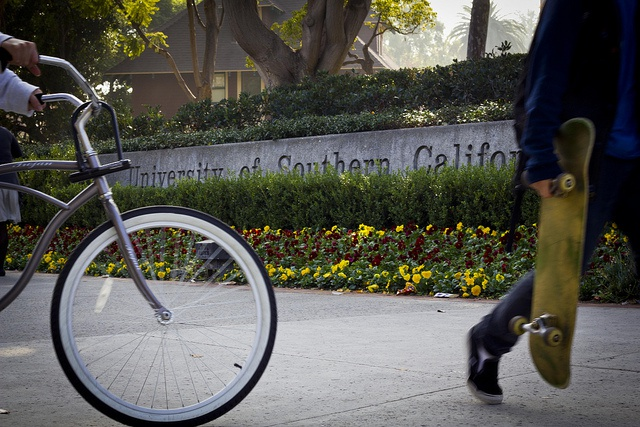Describe the objects in this image and their specific colors. I can see bicycle in black, darkgray, gray, and lightgray tones, people in black, navy, gray, and maroon tones, skateboard in black, olive, and gray tones, and people in black and gray tones in this image. 